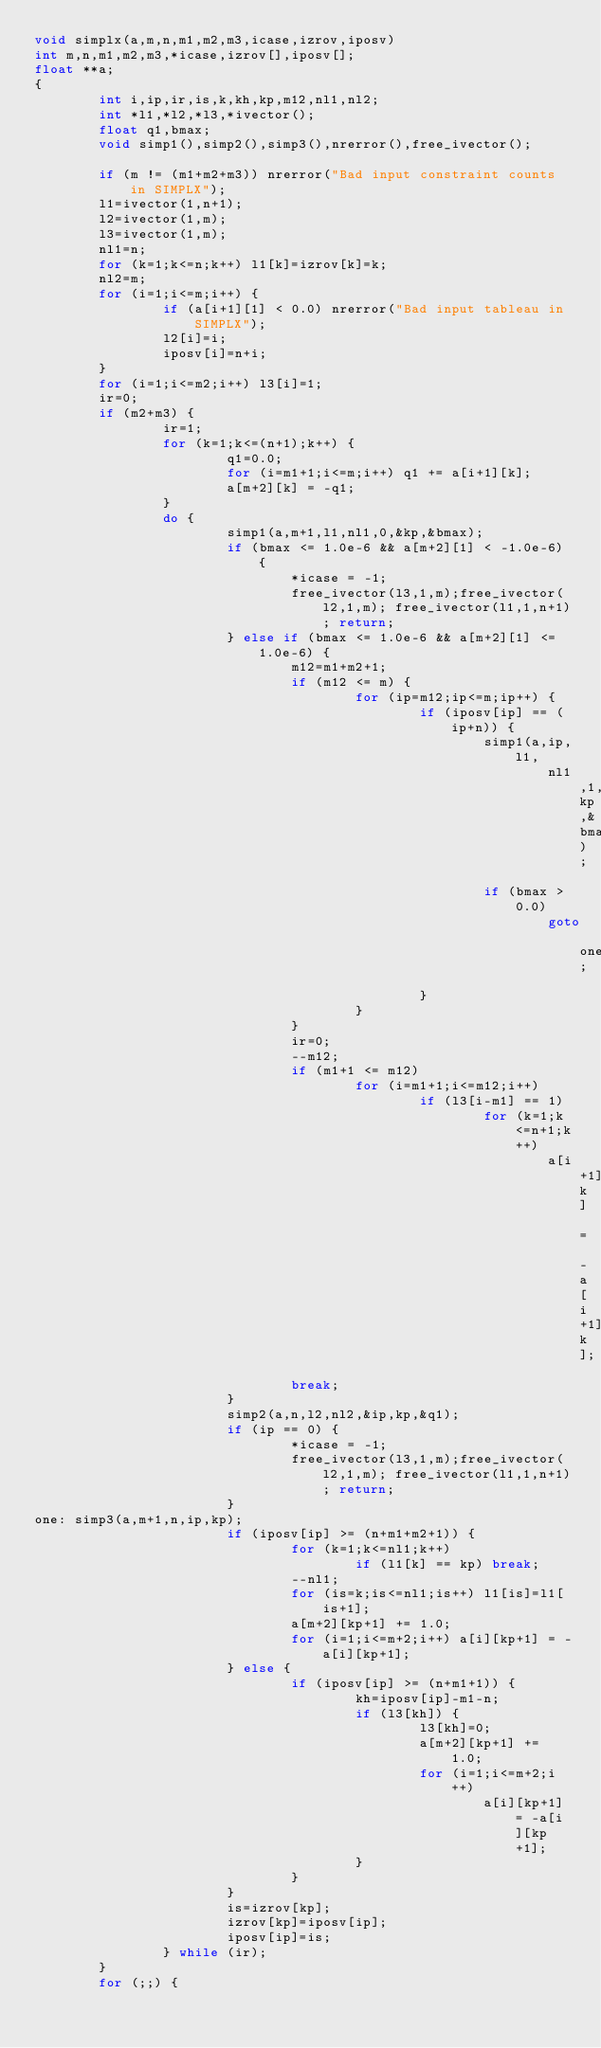<code> <loc_0><loc_0><loc_500><loc_500><_C_>void simplx(a,m,n,m1,m2,m3,icase,izrov,iposv)
int m,n,m1,m2,m3,*icase,izrov[],iposv[];
float **a;
{
        int i,ip,ir,is,k,kh,kp,m12,nl1,nl2;
        int *l1,*l2,*l3,*ivector();
        float q1,bmax;
        void simp1(),simp2(),simp3(),nrerror(),free_ivector();

        if (m != (m1+m2+m3)) nrerror("Bad input constraint counts in SIMPLX");
        l1=ivector(1,n+1);
        l2=ivector(1,m);
        l3=ivector(1,m);
        nl1=n;
        for (k=1;k<=n;k++) l1[k]=izrov[k]=k;
        nl2=m;
        for (i=1;i<=m;i++) {
                if (a[i+1][1] < 0.0) nrerror("Bad input tableau in SIMPLX");
                l2[i]=i;
                iposv[i]=n+i;
        }
        for (i=1;i<=m2;i++) l3[i]=1;
        ir=0;
        if (m2+m3) {
                ir=1;
                for (k=1;k<=(n+1);k++) {
                        q1=0.0;
                        for (i=m1+1;i<=m;i++) q1 += a[i+1][k];
                        a[m+2][k] = -q1;
                }
                do {
                        simp1(a,m+1,l1,nl1,0,&kp,&bmax);
                        if (bmax <= 1.0e-6 && a[m+2][1] < -1.0e-6) {
                                *icase = -1;
                                free_ivector(l3,1,m);free_ivector(l2,1,m); free_ivector(l1,1,n+1); return;
                        } else if (bmax <= 1.0e-6 && a[m+2][1] <= 1.0e-6) {
                                m12=m1+m2+1;
                                if (m12 <= m) {
                                        for (ip=m12;ip<=m;ip++) {
                                                if (iposv[ip] == (ip+n)) {
                                                        simp1(a,ip,l1,
                                                                nl1,1,&kp,&bmax);
                                                        if (bmax > 0.0)
                                                                goto one;
                                                }
                                        }
                                }
                                ir=0;
                                --m12;
                                if (m1+1 <= m12)
                                        for (i=m1+1;i<=m12;i++)
                                                if (l3[i-m1] == 1)
                                                        for (k=1;k<=n+1;k++)
                                                                a[i+1][k] = -a[i+1][k];
                                break;
                        }
                        simp2(a,n,l2,nl2,&ip,kp,&q1);
                        if (ip == 0) {
                                *icase = -1;
                                free_ivector(l3,1,m);free_ivector(l2,1,m); free_ivector(l1,1,n+1); return;
                        }
one: simp3(a,m+1,n,ip,kp);
                        if (iposv[ip] >= (n+m1+m2+1)) {
                                for (k=1;k<=nl1;k++)
                                        if (l1[k] == kp) break;
                                --nl1;
                                for (is=k;is<=nl1;is++) l1[is]=l1[is+1];
                                a[m+2][kp+1] += 1.0;
                                for (i=1;i<=m+2;i++) a[i][kp+1] = -a[i][kp+1];
                        } else {
                                if (iposv[ip] >= (n+m1+1)) {
                                        kh=iposv[ip]-m1-n;
                                        if (l3[kh]) {
                                                l3[kh]=0;
                                                a[m+2][kp+1] += 1.0;
                                                for (i=1;i<=m+2;i++)
                                                        a[i][kp+1] = -a[i][kp+1];
                                        }
                                }
                        }
                        is=izrov[kp];
                        izrov[kp]=iposv[ip];
                        iposv[ip]=is;
                } while (ir);
        }
        for (;;) {</code> 